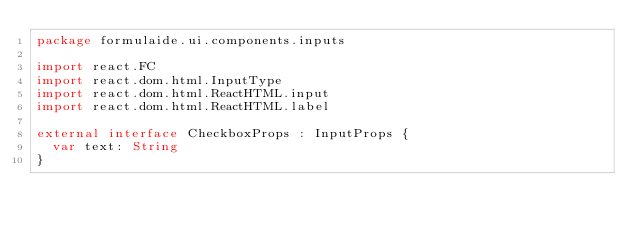Convert code to text. <code><loc_0><loc_0><loc_500><loc_500><_Kotlin_>package formulaide.ui.components.inputs

import react.FC
import react.dom.html.InputType
import react.dom.html.ReactHTML.input
import react.dom.html.ReactHTML.label

external interface CheckboxProps : InputProps {
	var text: String
}
</code> 